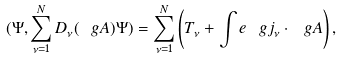Convert formula to latex. <formula><loc_0><loc_0><loc_500><loc_500>( \Psi , \sum _ { \nu = 1 } ^ { N } D _ { \nu } ( \ g A ) \Psi ) = \sum _ { \nu = 1 } ^ { N } \left ( T _ { \nu } + \int e \ g j _ { \nu } \cdot \ g A \right ) ,</formula> 